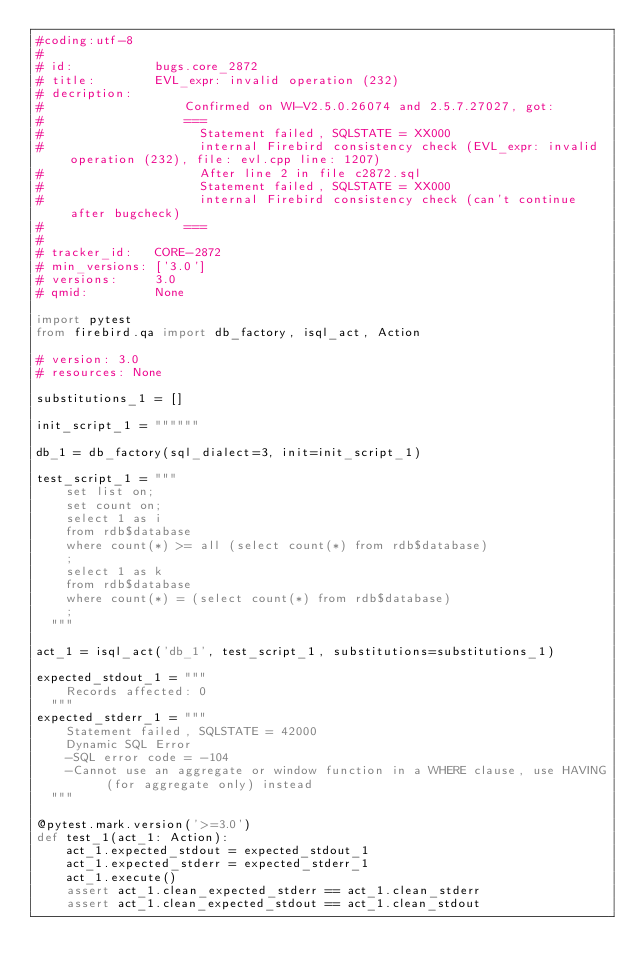Convert code to text. <code><loc_0><loc_0><loc_500><loc_500><_Python_>#coding:utf-8
#
# id:           bugs.core_2872
# title:        EVL_expr: invalid operation (232)
# decription:   
#                   Confirmed on WI-V2.5.0.26074 and 2.5.7.27027, got:
#                   ===
#                     Statement failed, SQLSTATE = XX000
#                     internal Firebird consistency check (EVL_expr: invalid operation (232), file: evl.cpp line: 1207)
#                     After line 2 in file c2872.sql
#                     Statement failed, SQLSTATE = XX000
#                     internal Firebird consistency check (can't continue after bugcheck)
#                   ===
#                
# tracker_id:   CORE-2872
# min_versions: ['3.0']
# versions:     3.0
# qmid:         None

import pytest
from firebird.qa import db_factory, isql_act, Action

# version: 3.0
# resources: None

substitutions_1 = []

init_script_1 = """"""

db_1 = db_factory(sql_dialect=3, init=init_script_1)

test_script_1 = """
    set list on;
    set count on;
    select 1 as i 
    from rdb$database
    where count(*) >= all (select count(*) from rdb$database)
    ;
    select 1 as k 
    from rdb$database
    where count(*) = (select count(*) from rdb$database)
    ;
  """

act_1 = isql_act('db_1', test_script_1, substitutions=substitutions_1)

expected_stdout_1 = """
    Records affected: 0
  """
expected_stderr_1 = """
    Statement failed, SQLSTATE = 42000
    Dynamic SQL Error
    -SQL error code = -104
    -Cannot use an aggregate or window function in a WHERE clause, use HAVING (for aggregate only) instead
  """

@pytest.mark.version('>=3.0')
def test_1(act_1: Action):
    act_1.expected_stdout = expected_stdout_1
    act_1.expected_stderr = expected_stderr_1
    act_1.execute()
    assert act_1.clean_expected_stderr == act_1.clean_stderr
    assert act_1.clean_expected_stdout == act_1.clean_stdout

</code> 